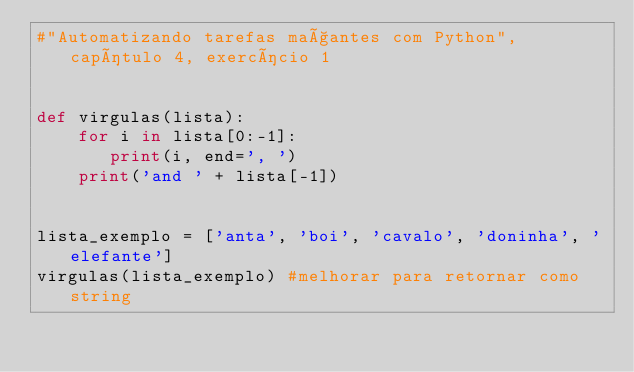<code> <loc_0><loc_0><loc_500><loc_500><_Python_>#"Automatizando tarefas maçantes com Python", capítulo 4, exercício 1


def virgulas(lista):
    for i in lista[0:-1]:
       print(i, end=', ')
    print('and ' + lista[-1])
         

lista_exemplo = ['anta', 'boi', 'cavalo', 'doninha', 'elefante']
virgulas(lista_exemplo) #melhorar para retornar como string
</code> 